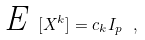<formula> <loc_0><loc_0><loc_500><loc_500>\emph { E } [ X ^ { k } ] = c _ { k } I _ { p } \ ,</formula> 